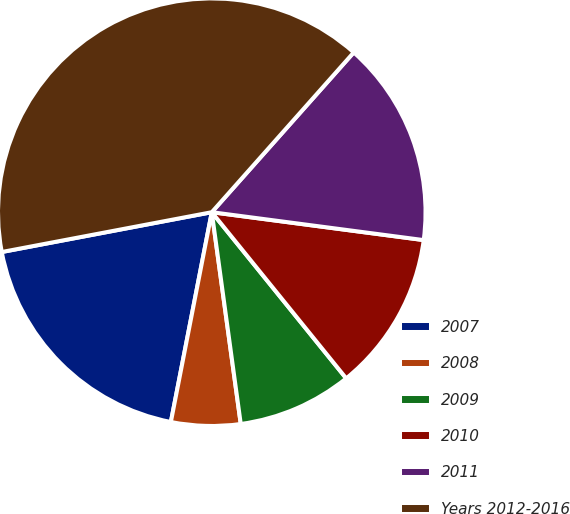<chart> <loc_0><loc_0><loc_500><loc_500><pie_chart><fcel>2007<fcel>2008<fcel>2009<fcel>2010<fcel>2011<fcel>Years 2012-2016<nl><fcel>18.95%<fcel>5.23%<fcel>8.66%<fcel>12.09%<fcel>15.52%<fcel>39.54%<nl></chart> 